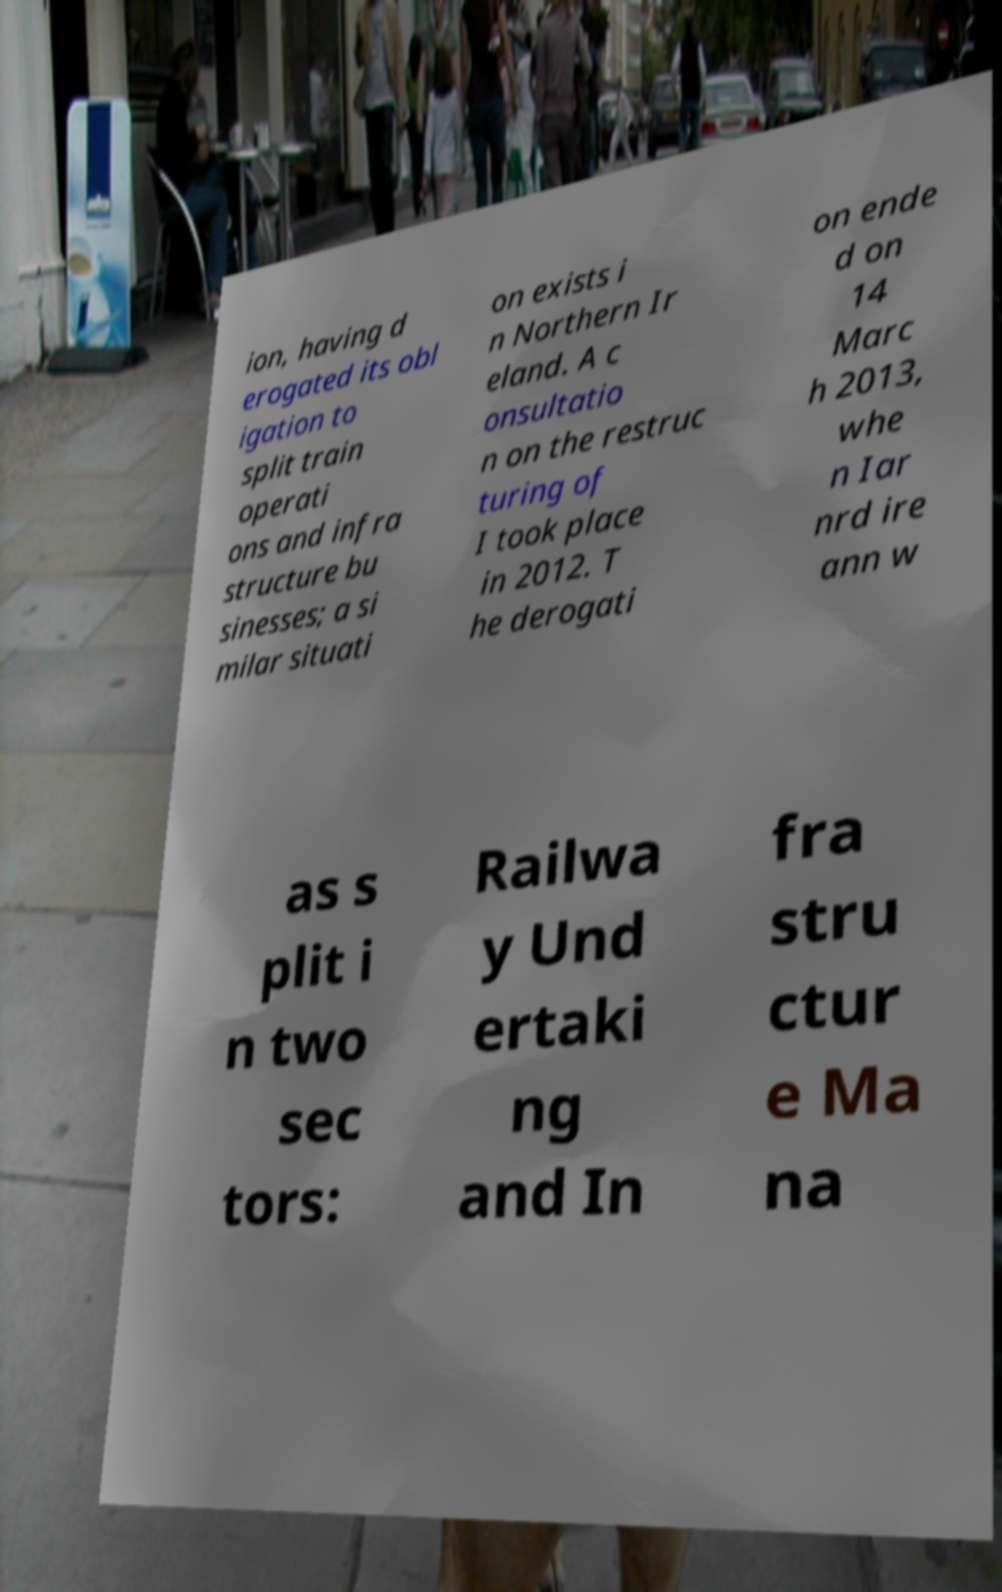For documentation purposes, I need the text within this image transcribed. Could you provide that? ion, having d erogated its obl igation to split train operati ons and infra structure bu sinesses; a si milar situati on exists i n Northern Ir eland. A c onsultatio n on the restruc turing of I took place in 2012. T he derogati on ende d on 14 Marc h 2013, whe n Iar nrd ire ann w as s plit i n two sec tors: Railwa y Und ertaki ng and In fra stru ctur e Ma na 